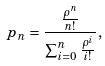Convert formula to latex. <formula><loc_0><loc_0><loc_500><loc_500>p _ { n } = \frac { \frac { \rho ^ { n } } { { n } ! } } { \sum _ { i = 0 } ^ { n } \frac { \rho ^ { i } } { i ! } } ,</formula> 